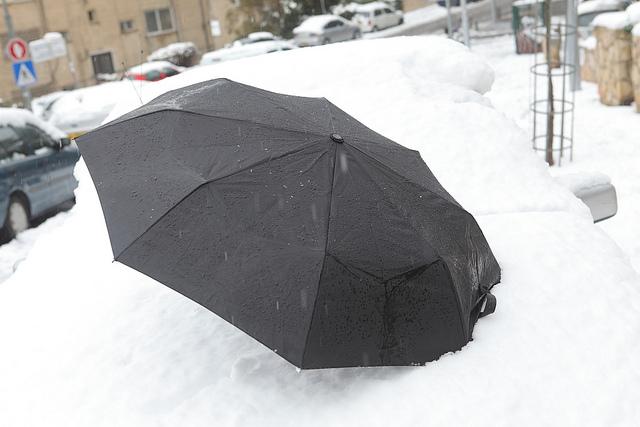What is covering the ground?
Concise answer only. Snow. Has this umbrella been abandoned?
Answer briefly. Yes. Is this picture in a tropical climate?
Be succinct. No. 